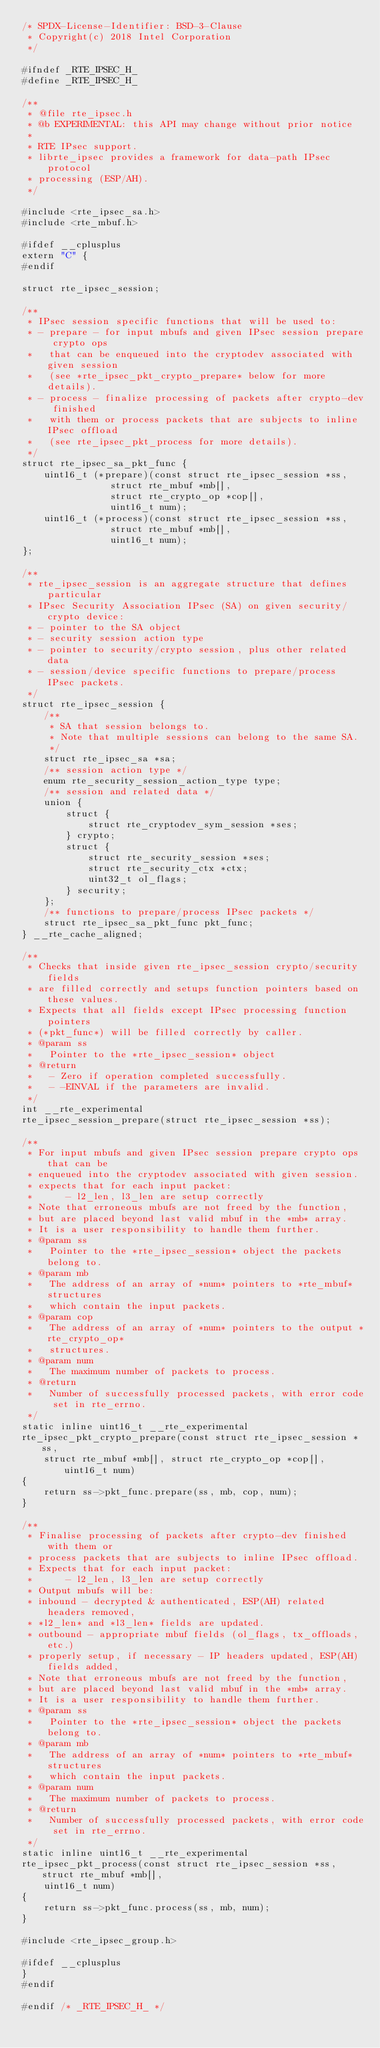<code> <loc_0><loc_0><loc_500><loc_500><_C_>/* SPDX-License-Identifier: BSD-3-Clause
 * Copyright(c) 2018 Intel Corporation
 */

#ifndef _RTE_IPSEC_H_
#define _RTE_IPSEC_H_

/**
 * @file rte_ipsec.h
 * @b EXPERIMENTAL: this API may change without prior notice
 *
 * RTE IPsec support.
 * librte_ipsec provides a framework for data-path IPsec protocol
 * processing (ESP/AH).
 */

#include <rte_ipsec_sa.h>
#include <rte_mbuf.h>

#ifdef __cplusplus
extern "C" {
#endif

struct rte_ipsec_session;

/**
 * IPsec session specific functions that will be used to:
 * - prepare - for input mbufs and given IPsec session prepare crypto ops
 *   that can be enqueued into the cryptodev associated with given session
 *   (see *rte_ipsec_pkt_crypto_prepare* below for more details).
 * - process - finalize processing of packets after crypto-dev finished
 *   with them or process packets that are subjects to inline IPsec offload
 *   (see rte_ipsec_pkt_process for more details).
 */
struct rte_ipsec_sa_pkt_func {
	uint16_t (*prepare)(const struct rte_ipsec_session *ss,
				struct rte_mbuf *mb[],
				struct rte_crypto_op *cop[],
				uint16_t num);
	uint16_t (*process)(const struct rte_ipsec_session *ss,
				struct rte_mbuf *mb[],
				uint16_t num);
};

/**
 * rte_ipsec_session is an aggregate structure that defines particular
 * IPsec Security Association IPsec (SA) on given security/crypto device:
 * - pointer to the SA object
 * - security session action type
 * - pointer to security/crypto session, plus other related data
 * - session/device specific functions to prepare/process IPsec packets.
 */
struct rte_ipsec_session {
	/**
	 * SA that session belongs to.
	 * Note that multiple sessions can belong to the same SA.
	 */
	struct rte_ipsec_sa *sa;
	/** session action type */
	enum rte_security_session_action_type type;
	/** session and related data */
	union {
		struct {
			struct rte_cryptodev_sym_session *ses;
		} crypto;
		struct {
			struct rte_security_session *ses;
			struct rte_security_ctx *ctx;
			uint32_t ol_flags;
		} security;
	};
	/** functions to prepare/process IPsec packets */
	struct rte_ipsec_sa_pkt_func pkt_func;
} __rte_cache_aligned;

/**
 * Checks that inside given rte_ipsec_session crypto/security fields
 * are filled correctly and setups function pointers based on these values.
 * Expects that all fields except IPsec processing function pointers
 * (*pkt_func*) will be filled correctly by caller.
 * @param ss
 *   Pointer to the *rte_ipsec_session* object
 * @return
 *   - Zero if operation completed successfully.
 *   - -EINVAL if the parameters are invalid.
 */
int __rte_experimental
rte_ipsec_session_prepare(struct rte_ipsec_session *ss);

/**
 * For input mbufs and given IPsec session prepare crypto ops that can be
 * enqueued into the cryptodev associated with given session.
 * expects that for each input packet:
 *      - l2_len, l3_len are setup correctly
 * Note that erroneous mbufs are not freed by the function,
 * but are placed beyond last valid mbuf in the *mb* array.
 * It is a user responsibility to handle them further.
 * @param ss
 *   Pointer to the *rte_ipsec_session* object the packets belong to.
 * @param mb
 *   The address of an array of *num* pointers to *rte_mbuf* structures
 *   which contain the input packets.
 * @param cop
 *   The address of an array of *num* pointers to the output *rte_crypto_op*
 *   structures.
 * @param num
 *   The maximum number of packets to process.
 * @return
 *   Number of successfully processed packets, with error code set in rte_errno.
 */
static inline uint16_t __rte_experimental
rte_ipsec_pkt_crypto_prepare(const struct rte_ipsec_session *ss,
	struct rte_mbuf *mb[], struct rte_crypto_op *cop[], uint16_t num)
{
	return ss->pkt_func.prepare(ss, mb, cop, num);
}

/**
 * Finalise processing of packets after crypto-dev finished with them or
 * process packets that are subjects to inline IPsec offload.
 * Expects that for each input packet:
 *      - l2_len, l3_len are setup correctly
 * Output mbufs will be:
 * inbound - decrypted & authenticated, ESP(AH) related headers removed,
 * *l2_len* and *l3_len* fields are updated.
 * outbound - appropriate mbuf fields (ol_flags, tx_offloads, etc.)
 * properly setup, if necessary - IP headers updated, ESP(AH) fields added,
 * Note that erroneous mbufs are not freed by the function,
 * but are placed beyond last valid mbuf in the *mb* array.
 * It is a user responsibility to handle them further.
 * @param ss
 *   Pointer to the *rte_ipsec_session* object the packets belong to.
 * @param mb
 *   The address of an array of *num* pointers to *rte_mbuf* structures
 *   which contain the input packets.
 * @param num
 *   The maximum number of packets to process.
 * @return
 *   Number of successfully processed packets, with error code set in rte_errno.
 */
static inline uint16_t __rte_experimental
rte_ipsec_pkt_process(const struct rte_ipsec_session *ss, struct rte_mbuf *mb[],
	uint16_t num)
{
	return ss->pkt_func.process(ss, mb, num);
}

#include <rte_ipsec_group.h>

#ifdef __cplusplus
}
#endif

#endif /* _RTE_IPSEC_H_ */
</code> 